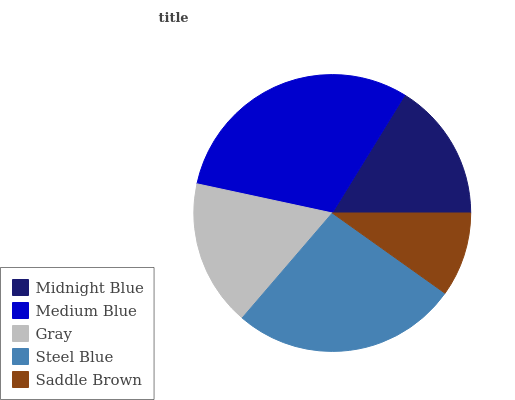Is Saddle Brown the minimum?
Answer yes or no. Yes. Is Medium Blue the maximum?
Answer yes or no. Yes. Is Gray the minimum?
Answer yes or no. No. Is Gray the maximum?
Answer yes or no. No. Is Medium Blue greater than Gray?
Answer yes or no. Yes. Is Gray less than Medium Blue?
Answer yes or no. Yes. Is Gray greater than Medium Blue?
Answer yes or no. No. Is Medium Blue less than Gray?
Answer yes or no. No. Is Gray the high median?
Answer yes or no. Yes. Is Gray the low median?
Answer yes or no. Yes. Is Steel Blue the high median?
Answer yes or no. No. Is Saddle Brown the low median?
Answer yes or no. No. 